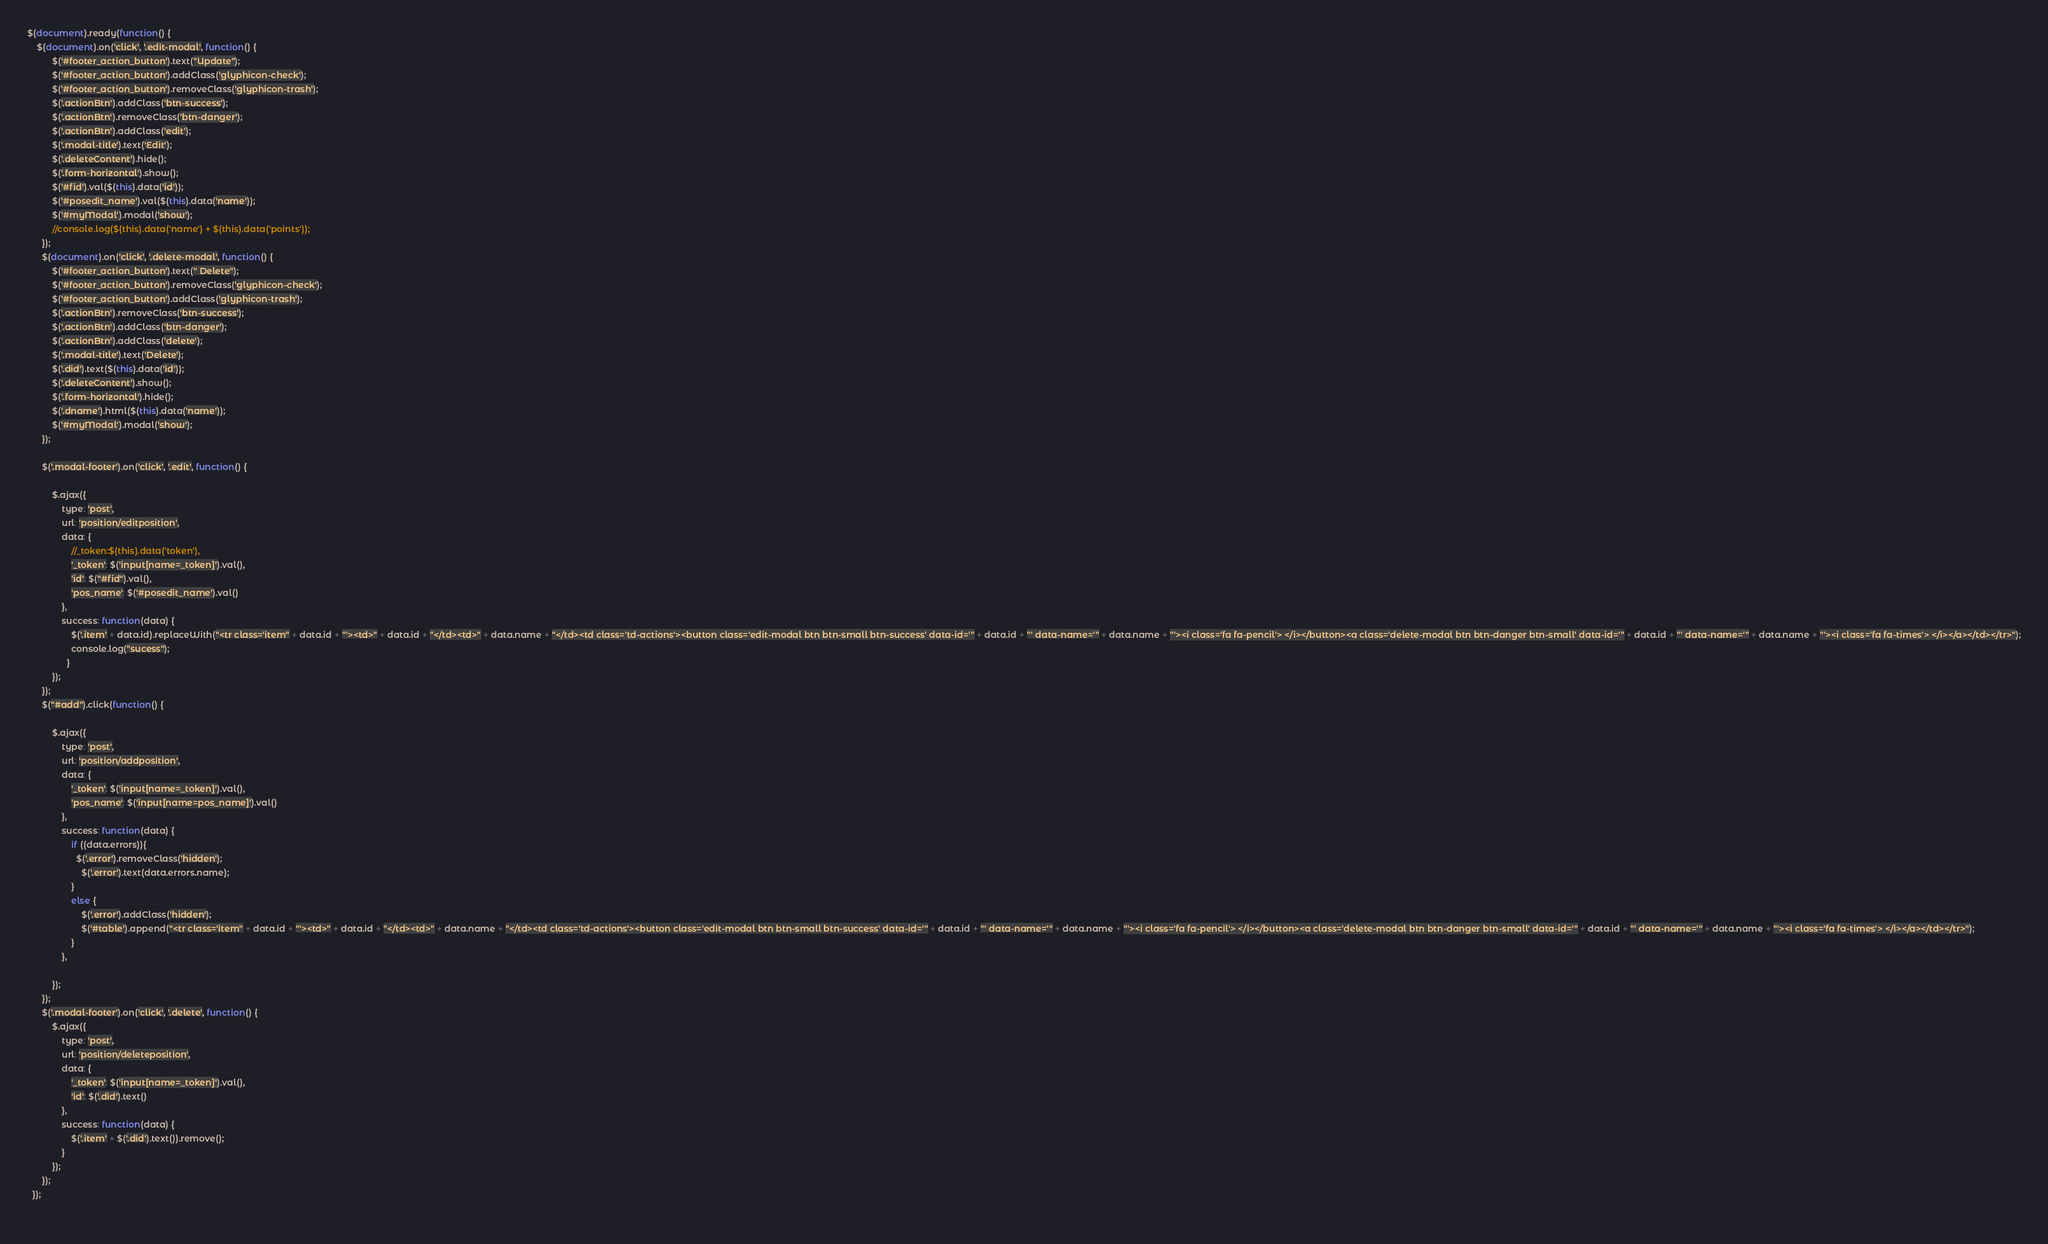<code> <loc_0><loc_0><loc_500><loc_500><_JavaScript_>$(document).ready(function() {
    $(document).on('click', '.edit-modal', function() {
          $('#footer_action_button').text("Update");
          $('#footer_action_button').addClass('glyphicon-check');
          $('#footer_action_button').removeClass('glyphicon-trash');
          $('.actionBtn').addClass('btn-success');
          $('.actionBtn').removeClass('btn-danger');
          $('.actionBtn').addClass('edit');
          $('.modal-title').text('Edit');
          $('.deleteContent').hide();
          $('.form-horizontal').show();
          $('#fid').val($(this).data('id'));
          $('#posedit_name').val($(this).data('name'));
          $('#myModal').modal('show');
          //console.log($(this).data('name') + $(this).data('points'));
      });
      $(document).on('click', '.delete-modal', function() {
          $('#footer_action_button').text(" Delete");
          $('#footer_action_button').removeClass('glyphicon-check');
          $('#footer_action_button').addClass('glyphicon-trash');
          $('.actionBtn').removeClass('btn-success');
          $('.actionBtn').addClass('btn-danger');
          $('.actionBtn').addClass('delete');
          $('.modal-title').text('Delete');
          $('.did').text($(this).data('id'));
          $('.deleteContent').show();
          $('.form-horizontal').hide();
          $('.dname').html($(this).data('name'));
          $('#myModal').modal('show');
      });
  
      $('.modal-footer').on('click', '.edit', function() {
  
          $.ajax({
              type: 'post',
              url: 'position/editposition',
              data: {
                  //_token:$(this).data('token'),
                  '_token': $('input[name=_token]').val(),
                  'id': $("#fid").val(),
                  'pos_name': $('#posedit_name').val()
              },
              success: function(data) {
                  $('.item' + data.id).replaceWith("<tr class='item" + data.id + "'><td>" + data.id + "</td><td>" + data.name + "</td><td class='td-actions'><button class='edit-modal btn btn-small btn-success' data-id='" + data.id + "' data-name='" + data.name + "'><i class='fa fa-pencil'> </i></button><a class='delete-modal btn btn-danger btn-small' data-id='" + data.id + "' data-name='" + data.name + "'><i class='fa fa-times'> </i></a></td></tr>");
                  console.log("sucess");
                }
          });
      });
      $("#add").click(function() {
  
          $.ajax({
              type: 'post',
              url: 'position/addposition',
              data: {
                  '_token': $('input[name=_token]').val(),
                  'pos_name': $('input[name=pos_name]').val()
              },
              success: function(data) {
                  if ((data.errors)){
                    $('.error').removeClass('hidden');
                      $('.error').text(data.errors.name);
                  }
                  else {
                      $('.error').addClass('hidden');
                      $('#table').append("<tr class='item" + data.id + "'><td>" + data.id + "</td><td>" + data.name + "</td><td class='td-actions'><button class='edit-modal btn btn-small btn-success' data-id='" + data.id + "' data-name='" + data.name + "'><i class='fa fa-pencil'> </i></button><a class='delete-modal btn btn-danger btn-small' data-id='" + data.id + "' data-name='" + data.name + "'><i class='fa fa-times'> </i></a></td></tr>");
                  }
              },
  
          });
      });
      $('.modal-footer').on('click', '.delete', function() {
          $.ajax({
              type: 'post',
              url: 'position/deleteposition',
              data: {
                  '_token': $('input[name=_token]').val(),
                  'id': $('.did').text()
              },
              success: function(data) {
                  $('.item' + $('.did').text()).remove();
              }
          });
      });
  });
  </code> 